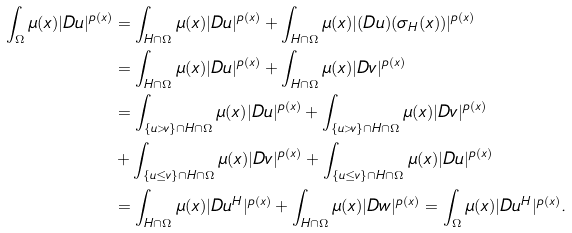Convert formula to latex. <formula><loc_0><loc_0><loc_500><loc_500>\int _ { \Omega } \mu ( x ) | D u | ^ { p ( x ) } & = \int _ { H \cap \Omega } \mu ( x ) | D u | ^ { p ( x ) } + \int _ { H \cap \Omega } \mu ( x ) | ( D u ) ( \sigma _ { H } ( x ) ) | ^ { p ( x ) } \\ & = \int _ { H \cap \Omega } \mu ( x ) | D u | ^ { p ( x ) } + \int _ { H \cap \Omega } \mu ( x ) | D v | ^ { p ( x ) } \\ & = \int _ { \{ u > v \} \cap H \cap \Omega } \mu ( x ) | D u | ^ { p ( x ) } + \int _ { \{ u > v \} \cap H \cap \Omega } \mu ( x ) | D v | ^ { p ( x ) } \\ & + \int _ { \{ u \leq v \} \cap H \cap \Omega } \mu ( x ) | D v | ^ { p ( x ) } + \int _ { \{ u \leq v \} \cap H \cap \Omega } \mu ( x ) | D u | ^ { p ( x ) } \\ & = \int _ { H \cap \Omega } \mu ( x ) | D u ^ { H } | ^ { p ( x ) } + \int _ { H \cap \Omega } \mu ( x ) | D w | ^ { p ( x ) } = \int _ { \Omega } \mu ( x ) | D u ^ { H } | ^ { p ( x ) } .</formula> 